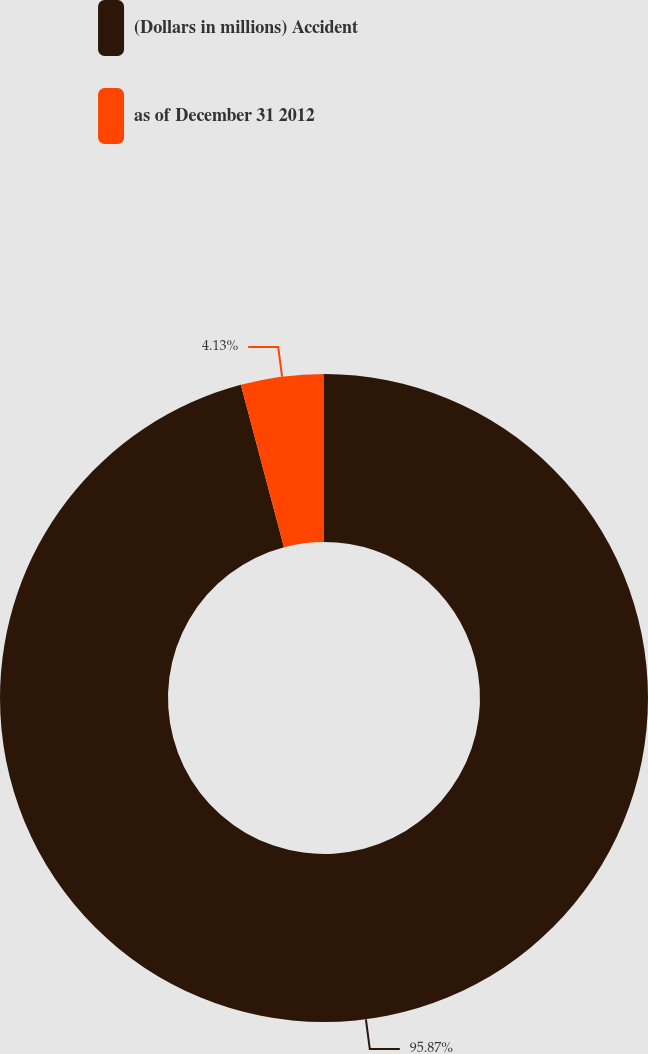Convert chart. <chart><loc_0><loc_0><loc_500><loc_500><pie_chart><fcel>(Dollars in millions) Accident<fcel>as of December 31 2012<nl><fcel>95.87%<fcel>4.13%<nl></chart> 